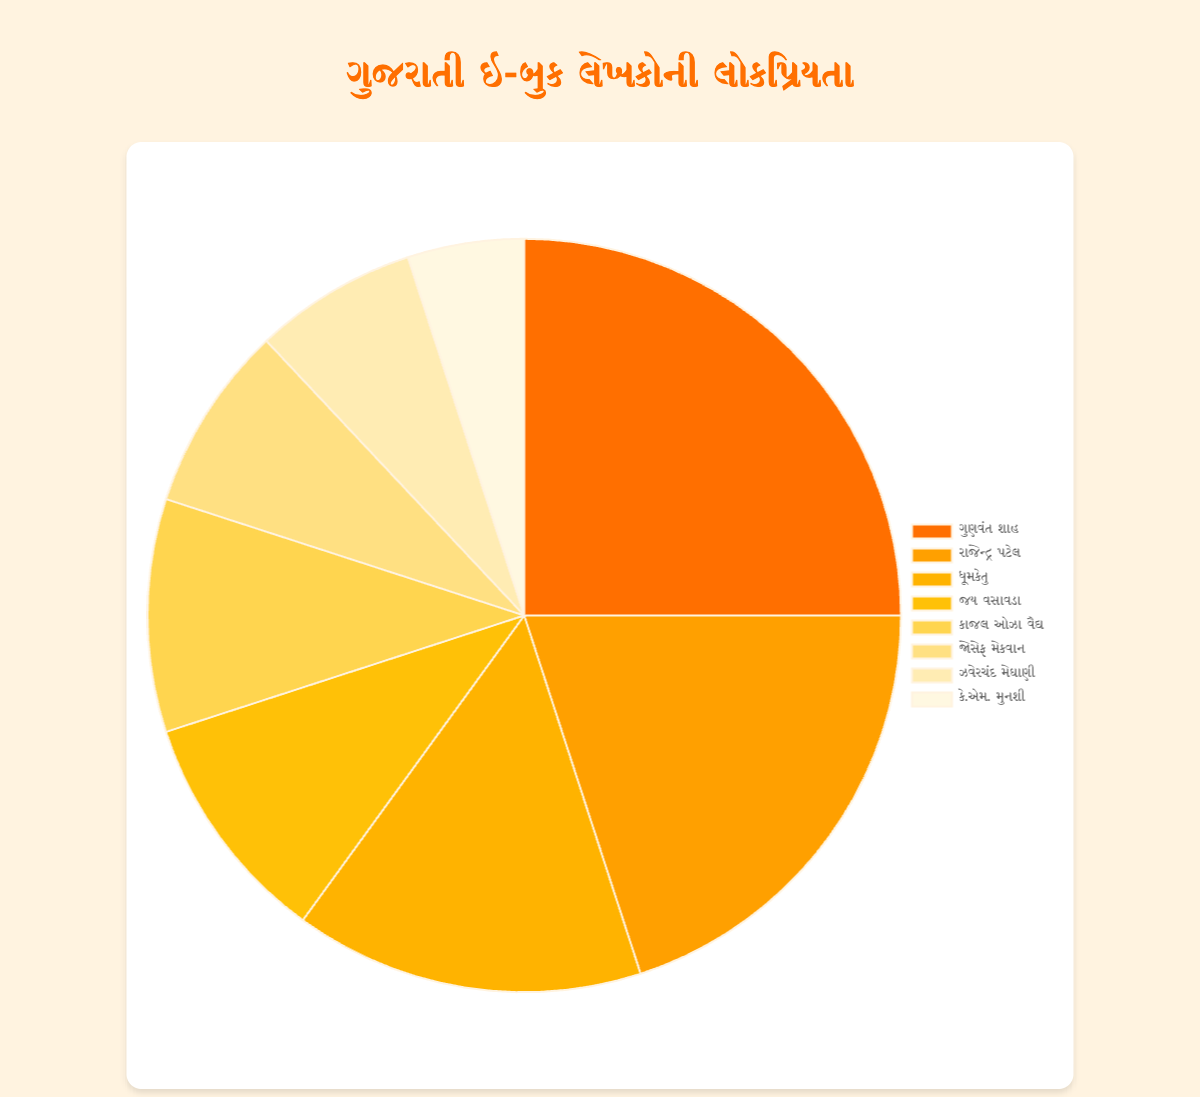What is the most popular author? The author with the highest percentage of popularity is the most popular one. According to the chart, Gunvant Shah holds the highest share with 25%.
Answer: Gunvant Shah How much more popular is Gunvant Shah compared to K.M. Munshi? Gunvant Shah has a popularity percentage of 25%, and K.M. Munshi has 5%. The difference is calculated as 25% - 5% = 20%.
Answer: 20% Which two authors have equal popularity percentages? By examining the chart, we see that Jay Vasavada and Kajali Oza Vaidya both have a popularity percentage of 10%.
Answer: Jay Vasavada and Kajali Oza Vaidya What is the combined popularity percentage of the three least popular authors? The three least popular authors are Joseph Macwan (8%), Zaverchand Meghani (7%), and K.M. Munshi (5%). Their combined percentage is 8% + 7% + 5% = 20%.
Answer: 20% What is the total percentage of popularity for authors with a popularity of 10% or less? The authors with 10% or less are Jay Vasavada (10%), Kajali Oza Vaidya (10%), Joseph Macwan (8%), Zaverchand Meghani (7%), and K.M. Munshi (5%). Summing these gives 10% + 10% + 8% + 7% + 5% = 40%.
Answer: 40% List the authors whose popularity percentage is greater than the average popularity percentage. The total percentage is 100% and there are 8 authors, so the average is 100% / 8 = 12.5%. The authors with a popularity greater than 12.5% are Gunvant Shah (25%), Rajendra Patel (20%), and Dhoomketu (15%).
Answer: Gunvant Shah, Rajendra Patel, and Dhoomketu What color represents Rajendra Patel? According to the chart legend, the colors are mapped in order: Gunvant Shah (orange), Rajendra Patel (amber), Dhoomketu (yellow), Jay Vasavada (light yellow), Kajali Oza Vaidya (lighter yellow), Joseph Macwan (even lighter yellow), Zaverchand Meghani (very light yellow), and K.M. Munshi (faint yellow). Therefore, Rajendra Patel is represented by amber.
Answer: Amber If Jay Vasavada's popularity increases by 5%, what will be his new percentage? Jay Vasavada currently has a popularity percentage of 10%. Adding 5% gives 10% + 5% = 15%.
Answer: 15% What's the difference in popularity percentage between Dhoomketu and the least popular author? Dhoomketu has a popularity percentage of 15% and the least popular author, K.M. Munshi, has 5%. The difference is 15% - 5% = 10%.
Answer: 10% 